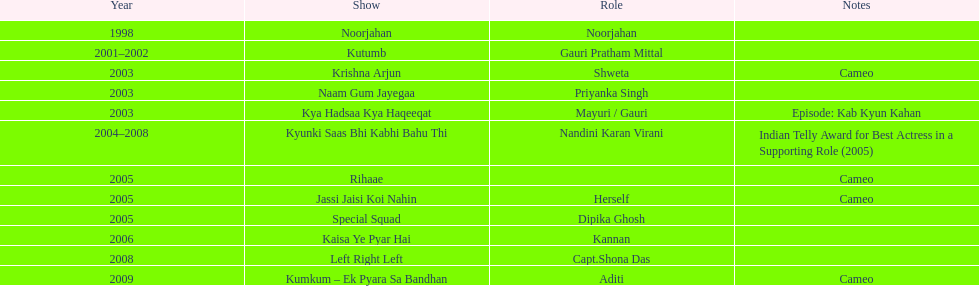Besides rihaae, in what other show did gauri tejwani cameo in 2005? Jassi Jaisi Koi Nahin. 